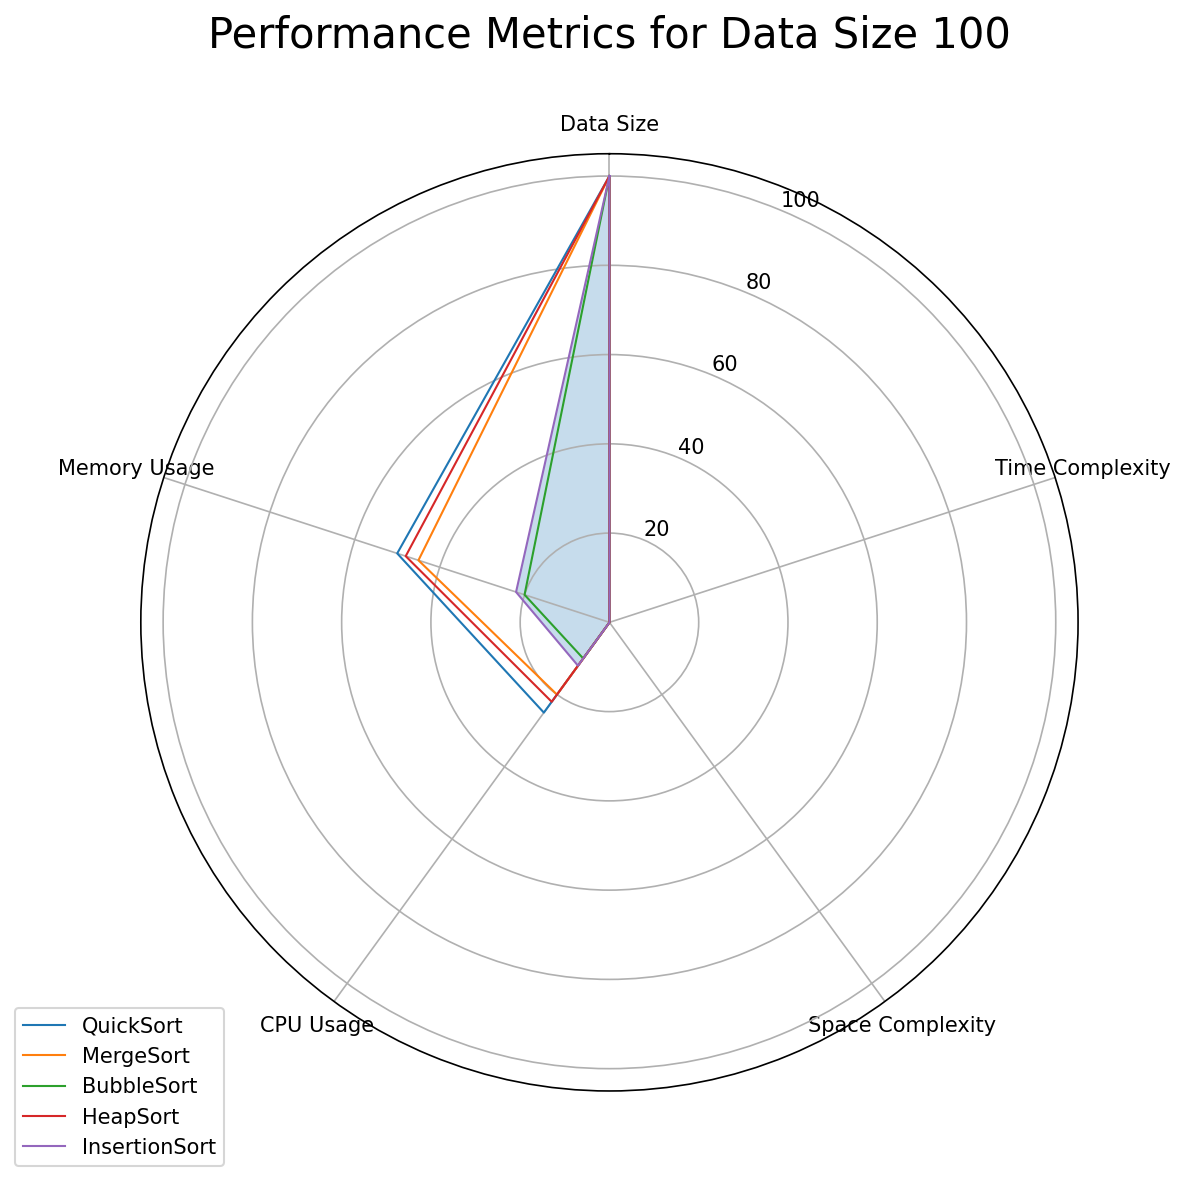Which algorithm has the lowest CPU Usage for data size 500? Referring to the radar chart for data size 500, we look at the CPU Usage axis. MergeSort has the lowest value on this axis compared to the other algorithms.
Answer: MergeSort Which algorithm shows the highest Memory Usage across all data sizes? By comparing the radar charts for each data size, we check the Memory Usage axis. QuickSort shows the highest value (60) in the data size 1000 chart, which is higher than the other algorithms.
Answer: QuickSort How does the Time Complexity of BubbleSort for data size 100 compare to InsertionSort for data size 500? We look at the Time Complexity axis for BubbleSort at data size 100 and InsertionSort at data size 500. BubbleSort at data size 100 has a higher Time Complexity (0.01) compared to InsertionSort at data size 500 (0.04).
Answer: InsertionSort is lower What is the sum of Memory Usage for HeapSort across all data sizes? First, we sum the Memory Usage for HeapSort at each data size (48 + 53 + 58). Doing the addition gives 48 + 53 = 101, and 101 + 58 = 159.
Answer: 159 Compare the overall performance metrics of QuickSort and HeapSort at data size 1000. Which algorithm demonstrates better performance? We compare each metric on the radar chart for data size 1000. QuickSort has lower Time Complexity (0.004 vs. 0.005), higher Space Complexity (0.04 vs. 0.03), higher CPU Usage (35 vs. 33), and higher Memory Usage (60 vs. 58). QuickSort is slightly more efficient in Time Complexity. However, HeapSort uses less memory overall. The decision depends on whether minimizing Time Complexity or Memory Usage is prioritized.
Answer: Varies based on priority Is the Time Complexity of MergeSort for data size 100 greater than HeapSort for data size 1000? On their respective radar charts, compare the Time Complexity values. MergeSort for data size 100 has a value of 0.002, while HeapSort for data size 1000 has a value of 0.005. Hence, MergeSort for data size 100 has a lower Time Complexity than HeapSort for data size 1000.
Answer: No Among QuickSort, MergeSort, and BubbleSort, for data size 1000, which has the least efficient Space Complexity? Examine the Space Complexity axis for all three algorithms on the radar chart for data size 1000. BubbleSort has the highest Space Complexity (0.03).
Answer: BubbleSort What's the average Memory Usage for InsertionSort across all data sizes? Add the Memory Usage values for InsertionSort at all data sizes (22, 28, 36) and divide by 3. The sum is 22 + 28 + 36 = 86, and the average is 86 / 3 ≈ 28.67.
Answer: 28.67 For data size 500, which algorithm has the lowest Space Complexity, and what is its value? Check the Space Complexity axis on the radar chart for data size 500. QuickSort, MergeSort, and HeapSort have Space Complexity values around 0.03 or lower. QuickSort has the lowest with 0.03.
Answer: QuickSort, 0.03 